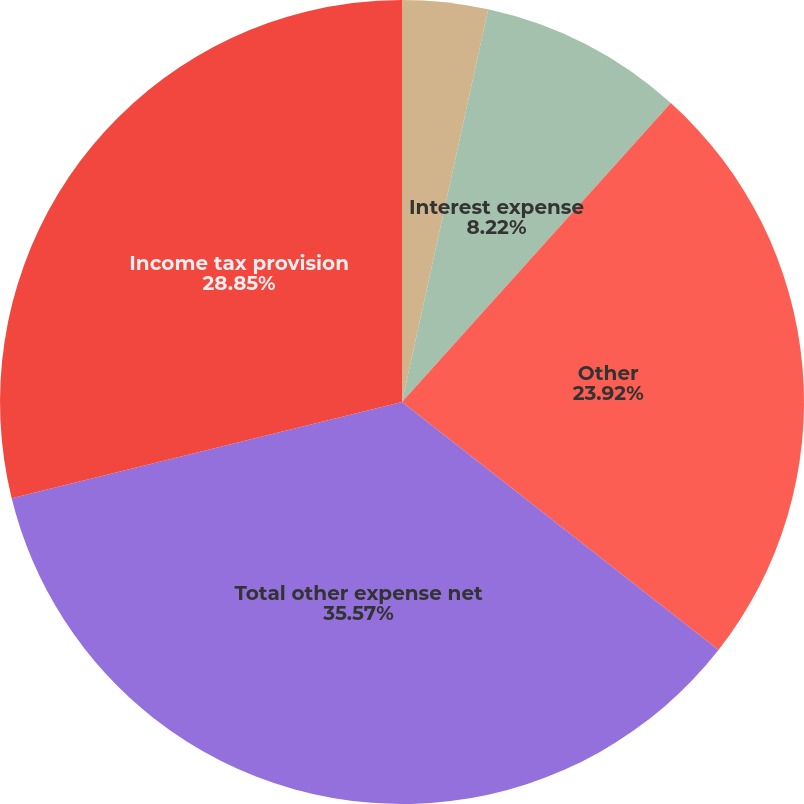<chart> <loc_0><loc_0><loc_500><loc_500><pie_chart><fcel>Interest income<fcel>Interest expense<fcel>Other<fcel>Total other expense net<fcel>Income tax provision<nl><fcel>3.44%<fcel>8.22%<fcel>23.92%<fcel>35.58%<fcel>28.85%<nl></chart> 